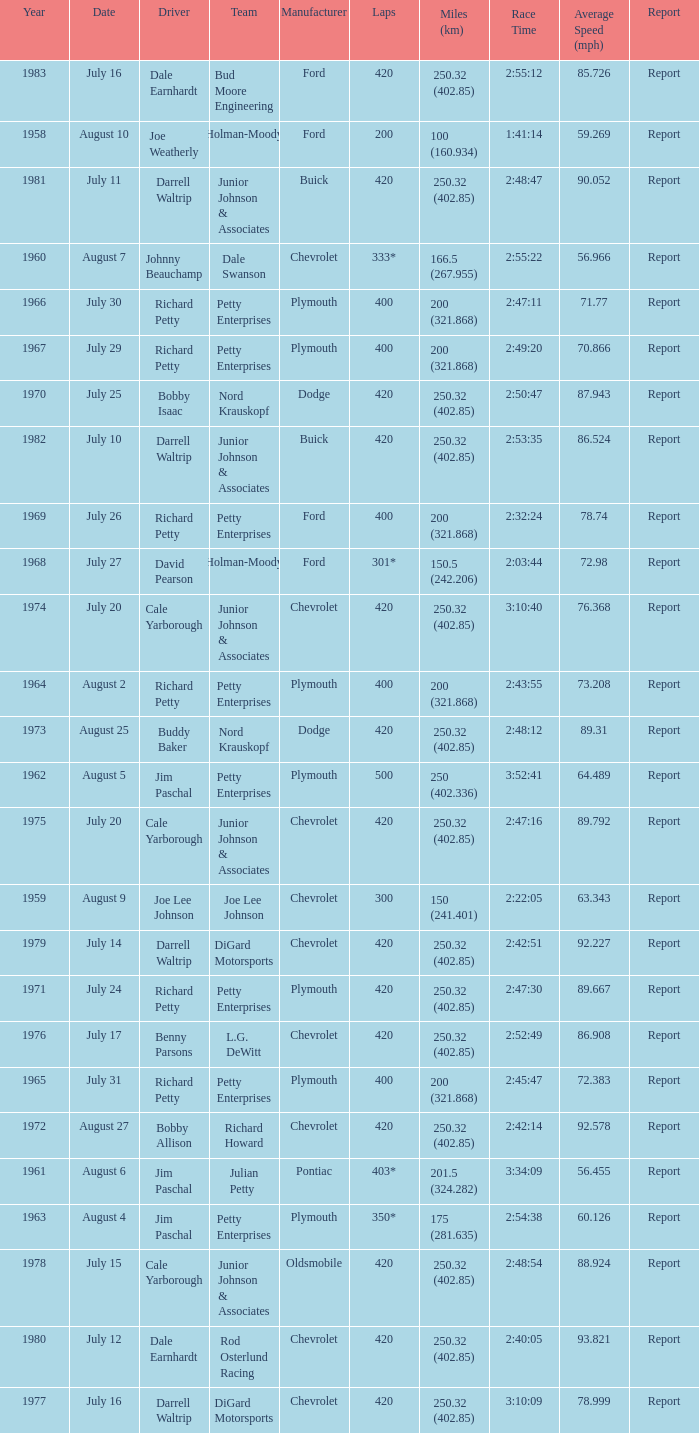How many races did Cale Yarborough win at an average speed of 88.924 mph? 1.0. 